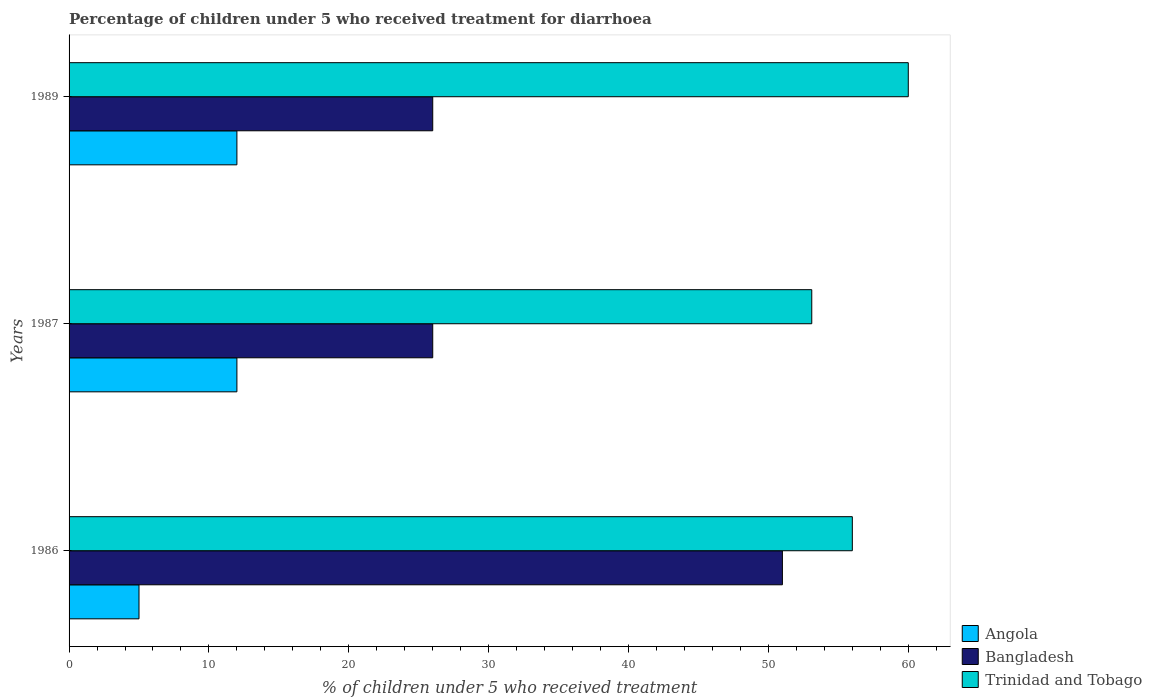How many different coloured bars are there?
Offer a very short reply. 3. How many groups of bars are there?
Ensure brevity in your answer.  3. Are the number of bars on each tick of the Y-axis equal?
Your answer should be very brief. Yes. What is the percentage of children who received treatment for diarrhoea  in Angola in 1989?
Make the answer very short. 12. Across all years, what is the maximum percentage of children who received treatment for diarrhoea  in Angola?
Provide a short and direct response. 12. Across all years, what is the minimum percentage of children who received treatment for diarrhoea  in Trinidad and Tobago?
Make the answer very short. 53.1. In which year was the percentage of children who received treatment for diarrhoea  in Trinidad and Tobago minimum?
Your answer should be very brief. 1987. What is the difference between the percentage of children who received treatment for diarrhoea  in Trinidad and Tobago in 1987 and the percentage of children who received treatment for diarrhoea  in Angola in 1989?
Keep it short and to the point. 41.1. What is the average percentage of children who received treatment for diarrhoea  in Angola per year?
Keep it short and to the point. 9.67. In the year 1987, what is the difference between the percentage of children who received treatment for diarrhoea  in Trinidad and Tobago and percentage of children who received treatment for diarrhoea  in Bangladesh?
Offer a very short reply. 27.1. In how many years, is the percentage of children who received treatment for diarrhoea  in Angola greater than 54 %?
Offer a terse response. 0. What is the ratio of the percentage of children who received treatment for diarrhoea  in Trinidad and Tobago in 1986 to that in 1987?
Ensure brevity in your answer.  1.05. Is the percentage of children who received treatment for diarrhoea  in Trinidad and Tobago in 1987 less than that in 1989?
Provide a succinct answer. Yes. Is the difference between the percentage of children who received treatment for diarrhoea  in Trinidad and Tobago in 1986 and 1987 greater than the difference between the percentage of children who received treatment for diarrhoea  in Bangladesh in 1986 and 1987?
Your answer should be very brief. No. What is the difference between the highest and the lowest percentage of children who received treatment for diarrhoea  in Trinidad and Tobago?
Your answer should be very brief. 6.9. How many bars are there?
Offer a very short reply. 9. Are all the bars in the graph horizontal?
Provide a short and direct response. Yes. What is the difference between two consecutive major ticks on the X-axis?
Give a very brief answer. 10. Where does the legend appear in the graph?
Ensure brevity in your answer.  Bottom right. How many legend labels are there?
Make the answer very short. 3. What is the title of the graph?
Offer a terse response. Percentage of children under 5 who received treatment for diarrhoea. What is the label or title of the X-axis?
Provide a short and direct response. % of children under 5 who received treatment. What is the label or title of the Y-axis?
Make the answer very short. Years. What is the % of children under 5 who received treatment of Angola in 1986?
Your answer should be compact. 5. What is the % of children under 5 who received treatment of Trinidad and Tobago in 1986?
Provide a succinct answer. 56. What is the % of children under 5 who received treatment in Bangladesh in 1987?
Offer a terse response. 26. What is the % of children under 5 who received treatment of Trinidad and Tobago in 1987?
Keep it short and to the point. 53.1. What is the % of children under 5 who received treatment of Trinidad and Tobago in 1989?
Give a very brief answer. 60. Across all years, what is the maximum % of children under 5 who received treatment of Angola?
Ensure brevity in your answer.  12. Across all years, what is the maximum % of children under 5 who received treatment of Trinidad and Tobago?
Your answer should be very brief. 60. Across all years, what is the minimum % of children under 5 who received treatment of Angola?
Provide a short and direct response. 5. Across all years, what is the minimum % of children under 5 who received treatment of Bangladesh?
Offer a very short reply. 26. Across all years, what is the minimum % of children under 5 who received treatment in Trinidad and Tobago?
Your answer should be compact. 53.1. What is the total % of children under 5 who received treatment in Bangladesh in the graph?
Make the answer very short. 103. What is the total % of children under 5 who received treatment in Trinidad and Tobago in the graph?
Offer a very short reply. 169.1. What is the difference between the % of children under 5 who received treatment in Angola in 1986 and that in 1987?
Your answer should be compact. -7. What is the difference between the % of children under 5 who received treatment of Angola in 1986 and that in 1989?
Ensure brevity in your answer.  -7. What is the difference between the % of children under 5 who received treatment in Bangladesh in 1986 and that in 1989?
Your response must be concise. 25. What is the difference between the % of children under 5 who received treatment of Trinidad and Tobago in 1986 and that in 1989?
Keep it short and to the point. -4. What is the difference between the % of children under 5 who received treatment in Angola in 1987 and that in 1989?
Your answer should be very brief. 0. What is the difference between the % of children under 5 who received treatment of Bangladesh in 1987 and that in 1989?
Give a very brief answer. 0. What is the difference between the % of children under 5 who received treatment of Angola in 1986 and the % of children under 5 who received treatment of Trinidad and Tobago in 1987?
Your response must be concise. -48.1. What is the difference between the % of children under 5 who received treatment of Angola in 1986 and the % of children under 5 who received treatment of Bangladesh in 1989?
Your answer should be compact. -21. What is the difference between the % of children under 5 who received treatment of Angola in 1986 and the % of children under 5 who received treatment of Trinidad and Tobago in 1989?
Ensure brevity in your answer.  -55. What is the difference between the % of children under 5 who received treatment of Bangladesh in 1986 and the % of children under 5 who received treatment of Trinidad and Tobago in 1989?
Offer a very short reply. -9. What is the difference between the % of children under 5 who received treatment in Angola in 1987 and the % of children under 5 who received treatment in Trinidad and Tobago in 1989?
Give a very brief answer. -48. What is the difference between the % of children under 5 who received treatment in Bangladesh in 1987 and the % of children under 5 who received treatment in Trinidad and Tobago in 1989?
Give a very brief answer. -34. What is the average % of children under 5 who received treatment in Angola per year?
Your answer should be compact. 9.67. What is the average % of children under 5 who received treatment in Bangladesh per year?
Offer a terse response. 34.33. What is the average % of children under 5 who received treatment of Trinidad and Tobago per year?
Give a very brief answer. 56.37. In the year 1986, what is the difference between the % of children under 5 who received treatment in Angola and % of children under 5 who received treatment in Bangladesh?
Offer a terse response. -46. In the year 1986, what is the difference between the % of children under 5 who received treatment of Angola and % of children under 5 who received treatment of Trinidad and Tobago?
Make the answer very short. -51. In the year 1987, what is the difference between the % of children under 5 who received treatment of Angola and % of children under 5 who received treatment of Trinidad and Tobago?
Ensure brevity in your answer.  -41.1. In the year 1987, what is the difference between the % of children under 5 who received treatment of Bangladesh and % of children under 5 who received treatment of Trinidad and Tobago?
Offer a terse response. -27.1. In the year 1989, what is the difference between the % of children under 5 who received treatment in Angola and % of children under 5 who received treatment in Trinidad and Tobago?
Your response must be concise. -48. In the year 1989, what is the difference between the % of children under 5 who received treatment of Bangladesh and % of children under 5 who received treatment of Trinidad and Tobago?
Give a very brief answer. -34. What is the ratio of the % of children under 5 who received treatment in Angola in 1986 to that in 1987?
Make the answer very short. 0.42. What is the ratio of the % of children under 5 who received treatment of Bangladesh in 1986 to that in 1987?
Make the answer very short. 1.96. What is the ratio of the % of children under 5 who received treatment of Trinidad and Tobago in 1986 to that in 1987?
Your answer should be very brief. 1.05. What is the ratio of the % of children under 5 who received treatment of Angola in 1986 to that in 1989?
Ensure brevity in your answer.  0.42. What is the ratio of the % of children under 5 who received treatment of Bangladesh in 1986 to that in 1989?
Your answer should be very brief. 1.96. What is the ratio of the % of children under 5 who received treatment in Trinidad and Tobago in 1986 to that in 1989?
Offer a very short reply. 0.93. What is the ratio of the % of children under 5 who received treatment of Trinidad and Tobago in 1987 to that in 1989?
Keep it short and to the point. 0.89. What is the difference between the highest and the second highest % of children under 5 who received treatment of Trinidad and Tobago?
Provide a succinct answer. 4. What is the difference between the highest and the lowest % of children under 5 who received treatment in Angola?
Your answer should be compact. 7. What is the difference between the highest and the lowest % of children under 5 who received treatment in Trinidad and Tobago?
Make the answer very short. 6.9. 